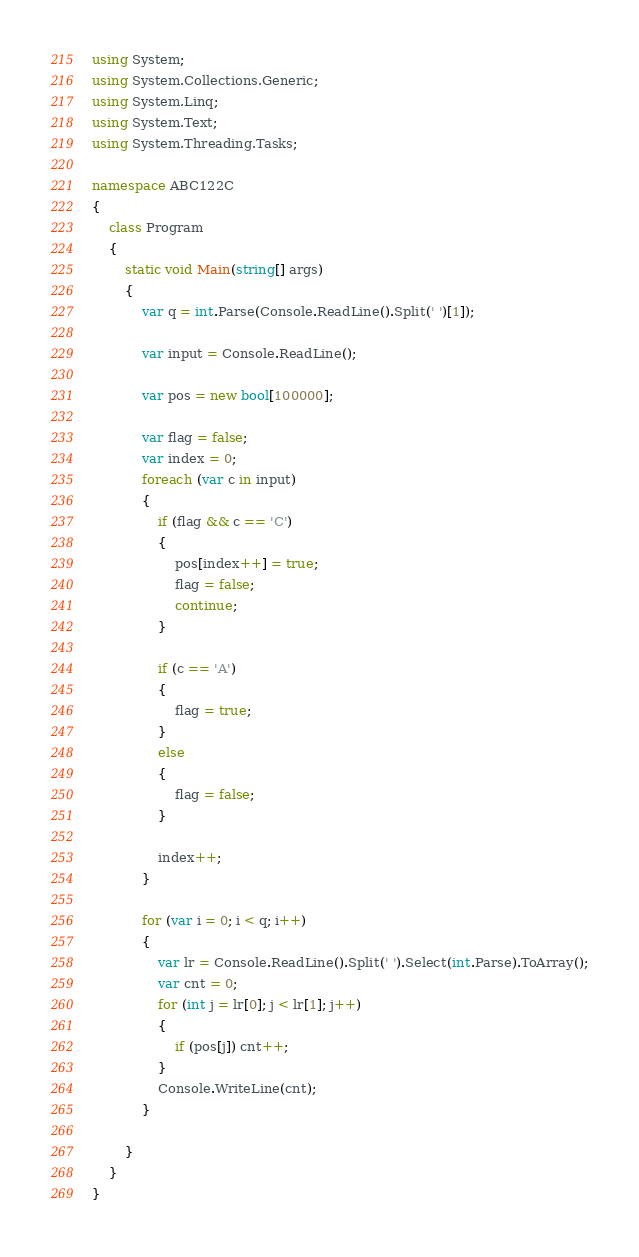Convert code to text. <code><loc_0><loc_0><loc_500><loc_500><_C#_>using System;
using System.Collections.Generic;
using System.Linq;
using System.Text;
using System.Threading.Tasks;

namespace ABC122C
{
    class Program
    {
        static void Main(string[] args)
        {
            var q = int.Parse(Console.ReadLine().Split(' ')[1]);

            var input = Console.ReadLine();

            var pos = new bool[100000];

            var flag = false;
            var index = 0;
            foreach (var c in input)
            {
                if (flag && c == 'C')
                {
                    pos[index++] = true;
                    flag = false;
                    continue;
                }

                if (c == 'A')
                {
                    flag = true;
                }
                else
                {
                    flag = false;
                }

                index++;
            }

            for (var i = 0; i < q; i++)
            {
                var lr = Console.ReadLine().Split(' ').Select(int.Parse).ToArray();
                var cnt = 0;
                for (int j = lr[0]; j < lr[1]; j++)
                {
                    if (pos[j]) cnt++;
                }
                Console.WriteLine(cnt);
            }

        }
    }
}
</code> 